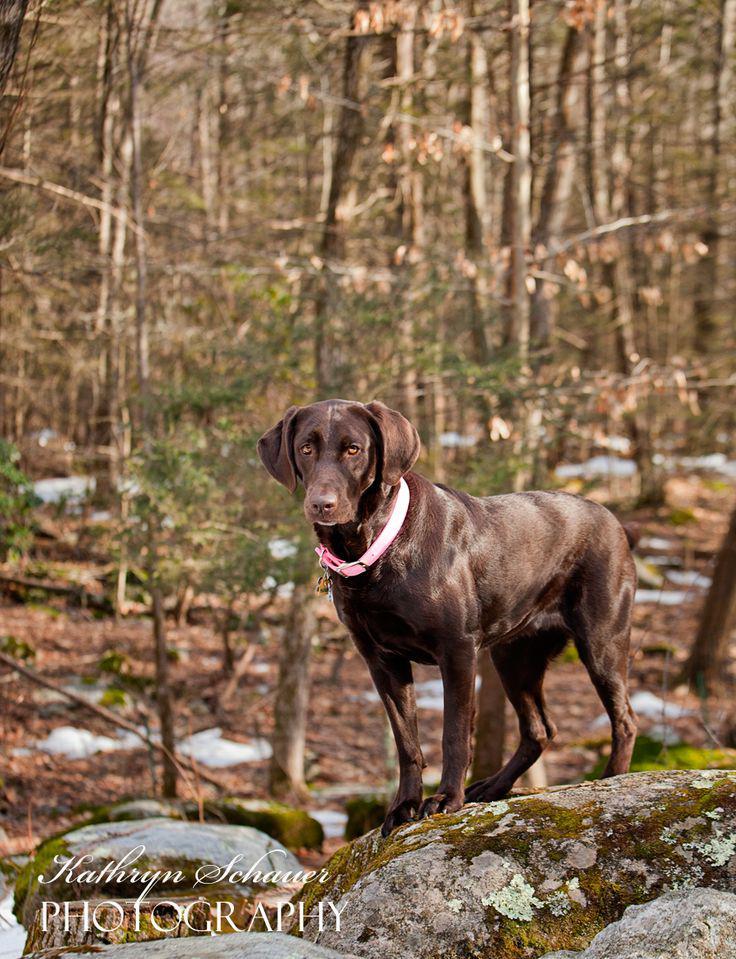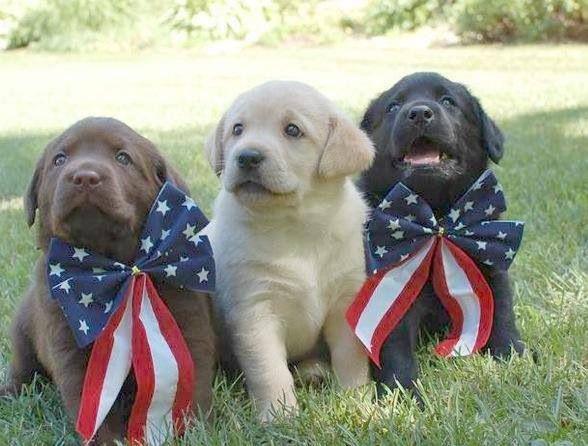The first image is the image on the left, the second image is the image on the right. Examine the images to the left and right. Is the description "There are no more than four labradors outside." accurate? Answer yes or no. Yes. The first image is the image on the left, the second image is the image on the right. For the images displayed, is the sentence "Left image shows one dog, which is solid brown and pictured outdoors." factually correct? Answer yes or no. Yes. 